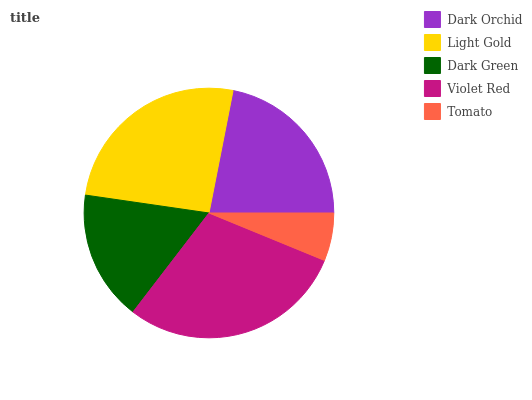Is Tomato the minimum?
Answer yes or no. Yes. Is Violet Red the maximum?
Answer yes or no. Yes. Is Light Gold the minimum?
Answer yes or no. No. Is Light Gold the maximum?
Answer yes or no. No. Is Light Gold greater than Dark Orchid?
Answer yes or no. Yes. Is Dark Orchid less than Light Gold?
Answer yes or no. Yes. Is Dark Orchid greater than Light Gold?
Answer yes or no. No. Is Light Gold less than Dark Orchid?
Answer yes or no. No. Is Dark Orchid the high median?
Answer yes or no. Yes. Is Dark Orchid the low median?
Answer yes or no. Yes. Is Violet Red the high median?
Answer yes or no. No. Is Violet Red the low median?
Answer yes or no. No. 